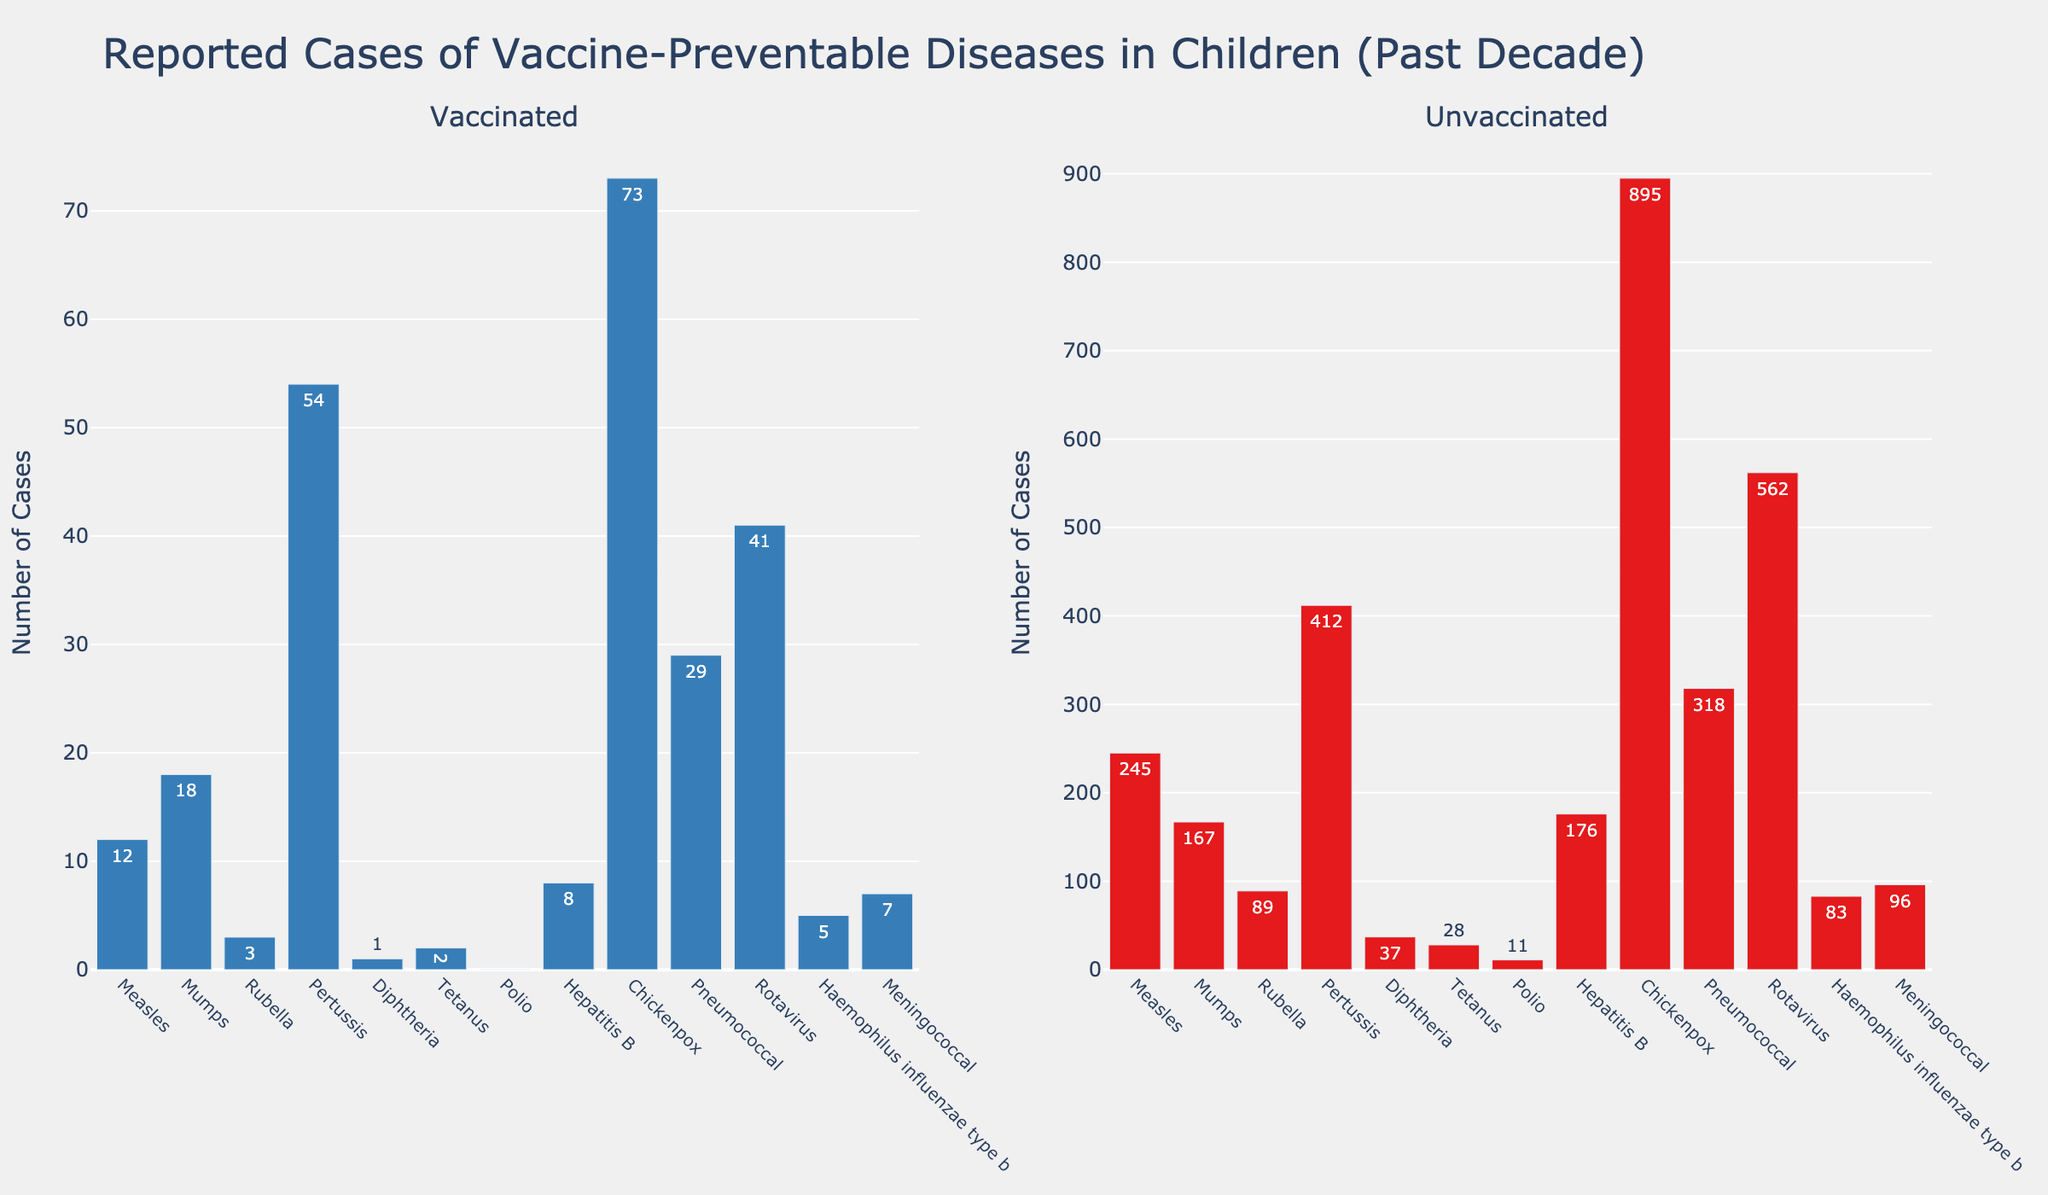Which disease has the highest number of reported cases among unvaccinated children? By observing the bar for unvaccinated children, the disease with the highest bar represents the highest number of cases. The Chickenpox bar is the tallest among the unvaccinated children.
Answer: Chickenpox How many more cases of Pertussis are there in unvaccinated children compared to vaccinated children? Observe the heights of the bars for Pertussis and subtract the number of cases in vaccinated children from the number of cases in unvaccinated children: 412 (unvaccinated) - 54 (vaccinated).
Answer: 358 Which disease has zero reported cases in vaccinated children? Look for the bar that represents zero cases among vaccinated children. The Polio bar is absent in the vaccinated section, indicating zero cases.
Answer: Polio What's the difference in the number of cases of Rubella between vaccinated and unvaccinated children? Observe the bars for Rubella and calculate the difference by subtracting the vaccinated cases from the unvaccinated cases: 89 (unvaccinated) - 3 (vaccinated).
Answer: 86 By how much does the number of Hepatitis B cases in unvaccinated children exceed those in vaccinated children? Compare the heights of the Hepatitis B bars and subtract the vaccinated cases from the unvaccinated cases: 176 (unvaccinated) - 8 (vaccinated).
Answer: 168 What is the total number of reported measles cases in both vaccinated and unvaccinated children? Sum the total number of cases for Measles by adding the vaccinated and unvaccinated cases together: 12 (vaccinated) + 245 (unvaccinated).
Answer: 257 Which disease has more than 50 reported cases in vaccinated children but less than 100 reported cases in unvaccinated children? Check the bars in the vaccinated section for those above 50 and then verify the corresponding bars in the unvaccinated section for those below 100. The disease that fits this criterion is Mumps.
Answer: Mumps What is the ratio of the number of Rotavirus cases in unvaccinated children to those in vaccinated children? Divide the number of Rotavirus cases in unvaccinated children by the number of cases in vaccinated children: 562 (unvaccinated) / 41 (vaccinated).
Answer: 13.7 How much higher is the peak value in the unvaccinated group compared to the vaccinated group? Identify the highest bar in the unvaccinated group and the highest bar in the vaccinated group and subtract the vaccinated peak from the unvaccinated peak: 895 (unvaccinated, Chickenpox) - 73 (vaccinated, Chickenpox).
Answer: 822 